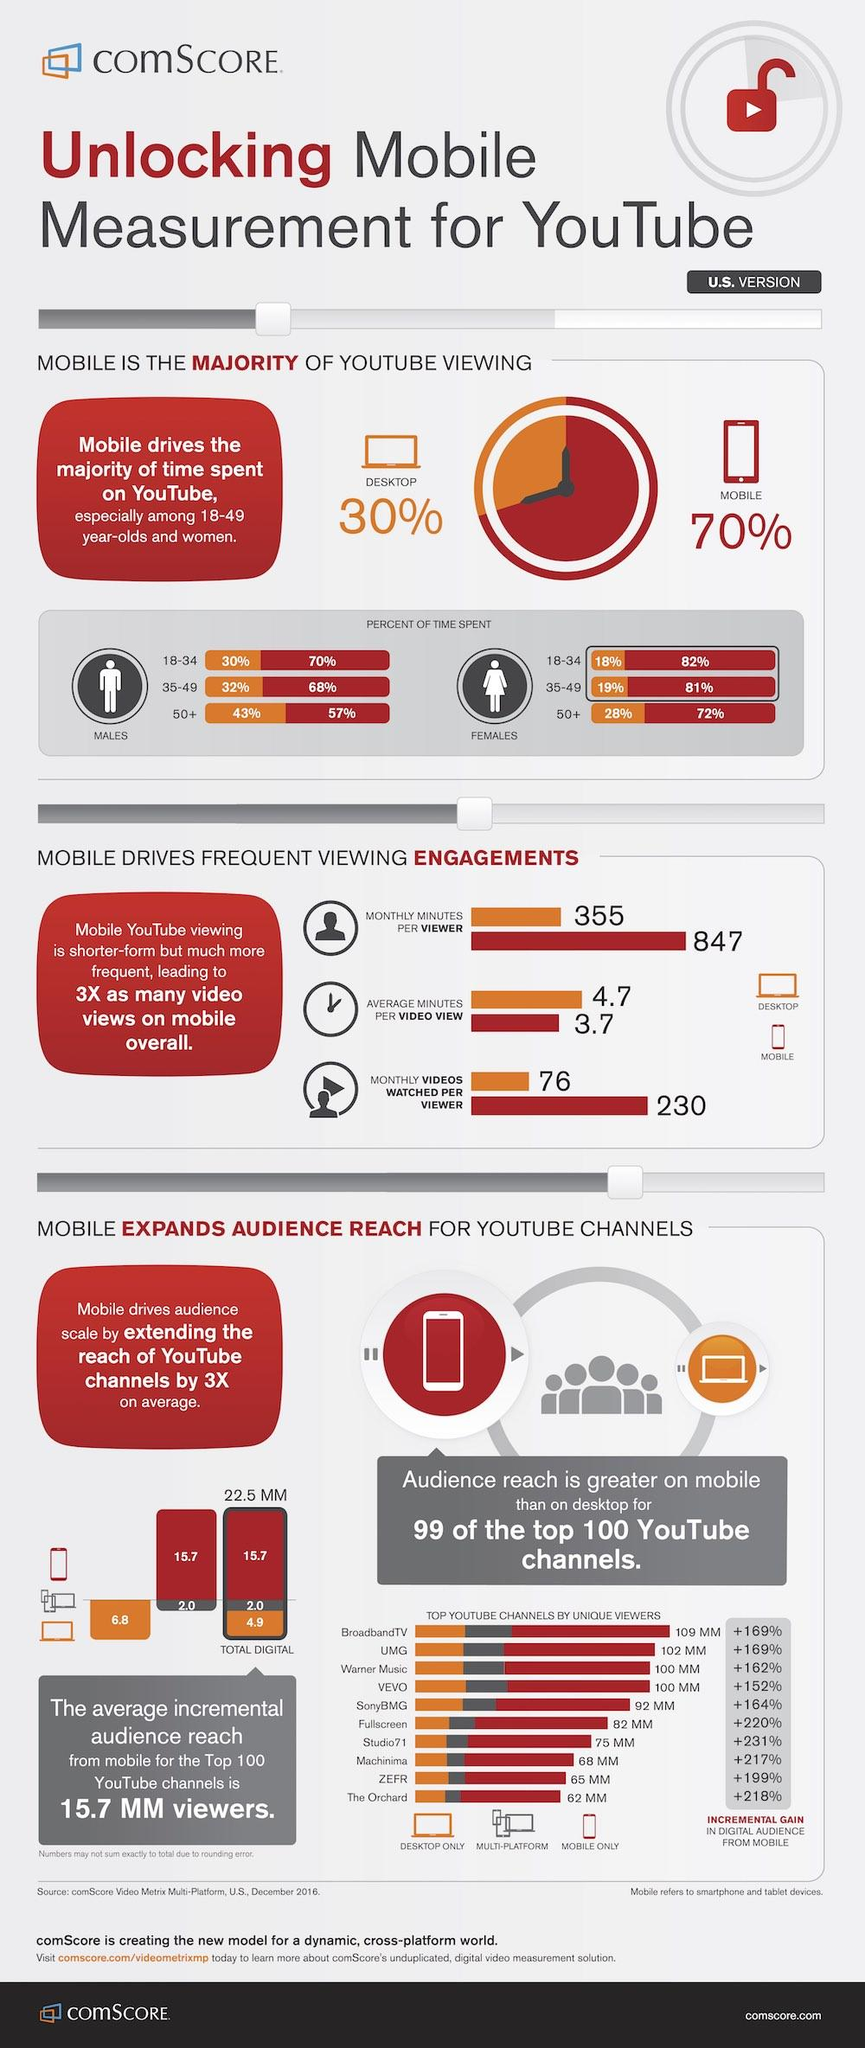Specify some key components in this picture. In the United States, the average number of monthly videos watched per mobile viewer is approximately 230. According to data, the age group of females in the United States that spent the least amount of time viewing YouTube on desktop devices was 18-34 year olds. According to a recent study, females in the 18-34 age group in the United States spend an estimated 82% of their time viewing YouTube on their mobile devices. According to recent data, the age group of males in the United States who spent the most time viewing YouTube on desktop computers was 50 years old and above. In the United States, males between the ages of 18 and 34 spend approximately 30% of their time watching videos on YouTube. 